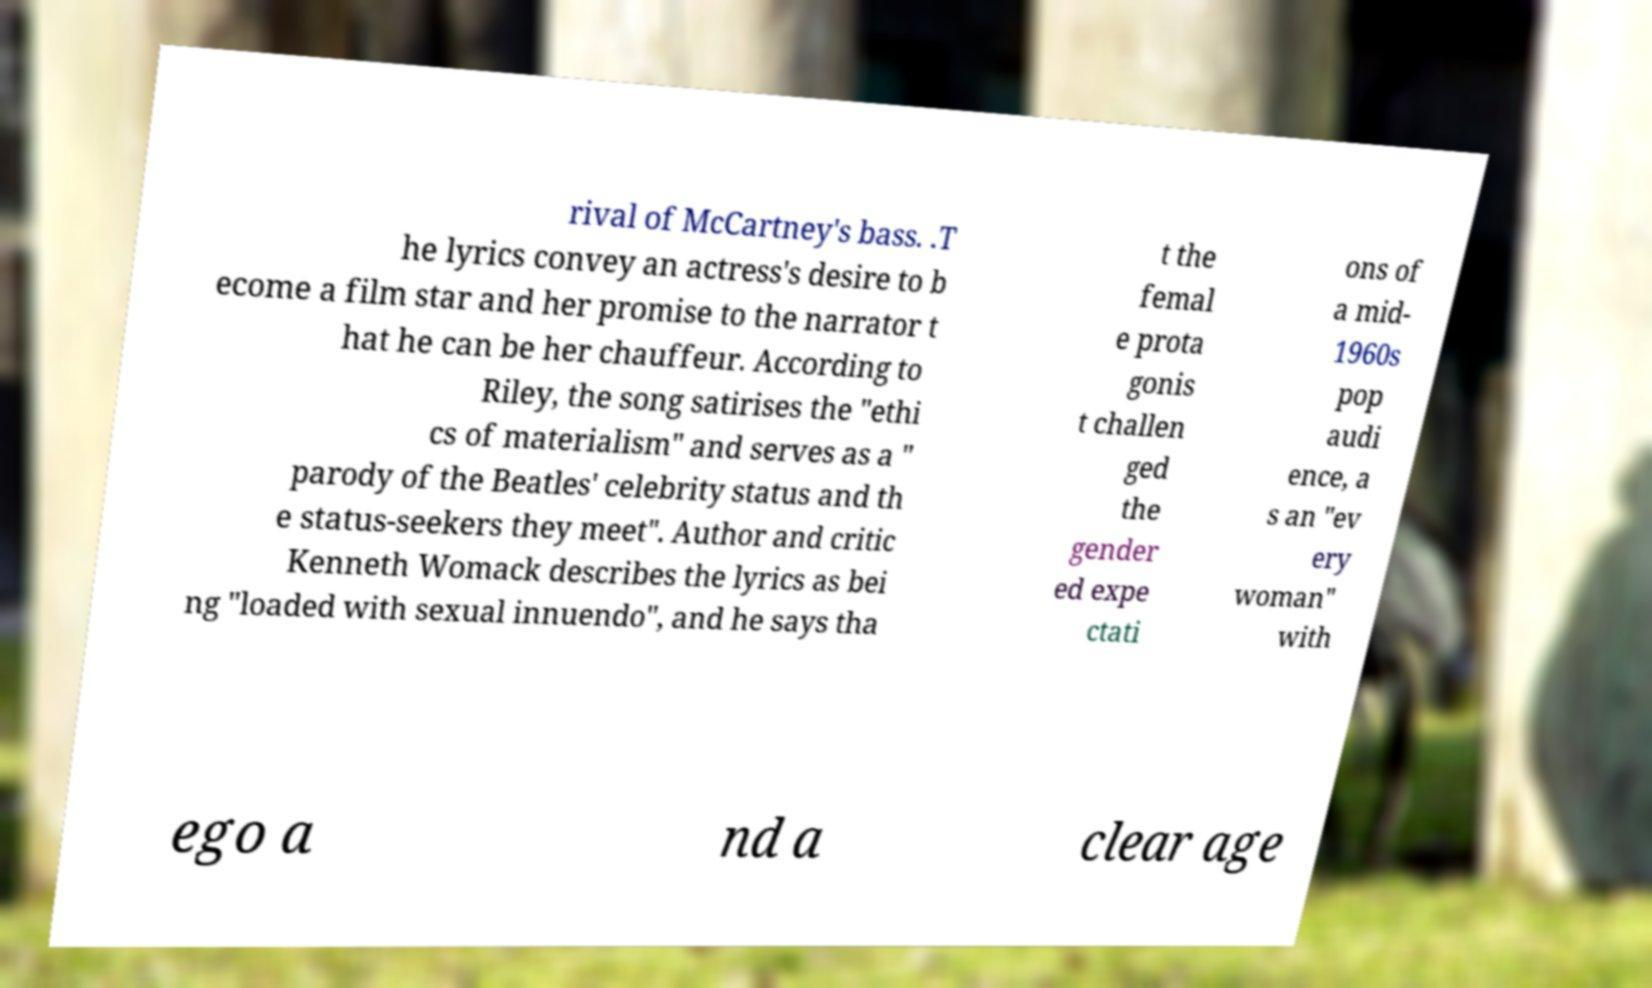Please read and relay the text visible in this image. What does it say? rival of McCartney's bass. .T he lyrics convey an actress's desire to b ecome a film star and her promise to the narrator t hat he can be her chauffeur. According to Riley, the song satirises the "ethi cs of materialism" and serves as a " parody of the Beatles' celebrity status and th e status-seekers they meet". Author and critic Kenneth Womack describes the lyrics as bei ng "loaded with sexual innuendo", and he says tha t the femal e prota gonis t challen ged the gender ed expe ctati ons of a mid- 1960s pop audi ence, a s an "ev ery woman" with ego a nd a clear age 